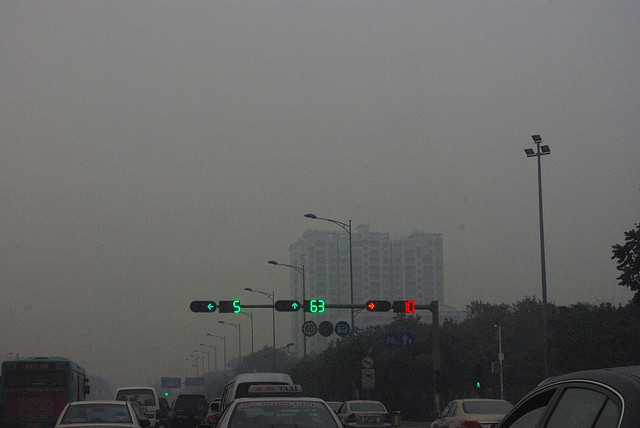Read and extract the text from this image. 5 63 TAXI 